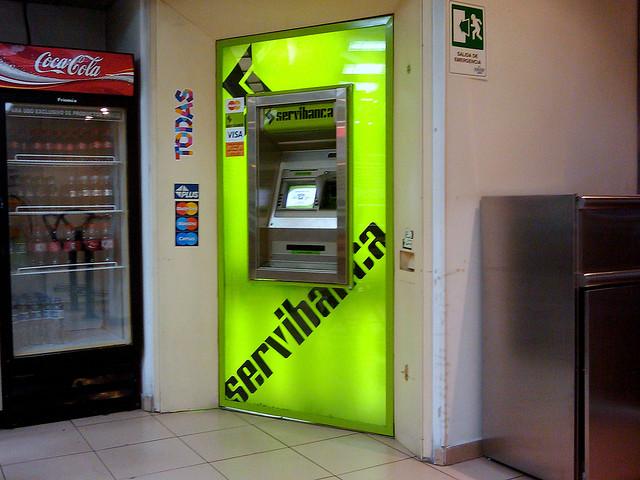Identify and read out the text in this image. Coca Cola TODAS servihanca VISA servihanca 